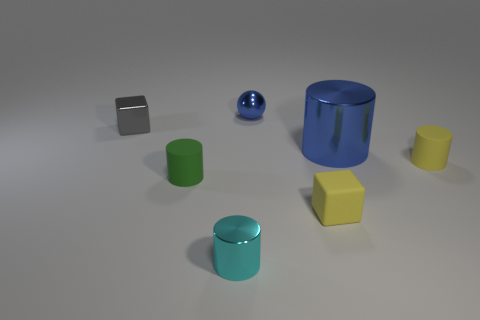Is there a matte cube of the same color as the metallic cube?
Your answer should be very brief. No. Are there any small yellow rubber cylinders?
Offer a terse response. Yes. There is a matte object that is left of the blue sphere; is it the same size as the shiny cube?
Provide a short and direct response. Yes. Are there fewer tiny gray objects than tiny purple shiny spheres?
Ensure brevity in your answer.  No. What is the shape of the green thing in front of the block that is behind the small rubber thing behind the green object?
Your response must be concise. Cylinder. Is there a brown thing that has the same material as the small gray cube?
Provide a short and direct response. No. Do the tiny metallic thing in front of the small gray cube and the small matte thing on the left side of the blue shiny sphere have the same color?
Your answer should be compact. No. Is the number of big blue cylinders that are right of the big metal cylinder less than the number of small gray shiny things?
Give a very brief answer. Yes. How many things are either big cylinders or things that are in front of the tiny yellow cylinder?
Provide a short and direct response. 4. What color is the tiny cube that is made of the same material as the small green cylinder?
Your answer should be very brief. Yellow. 